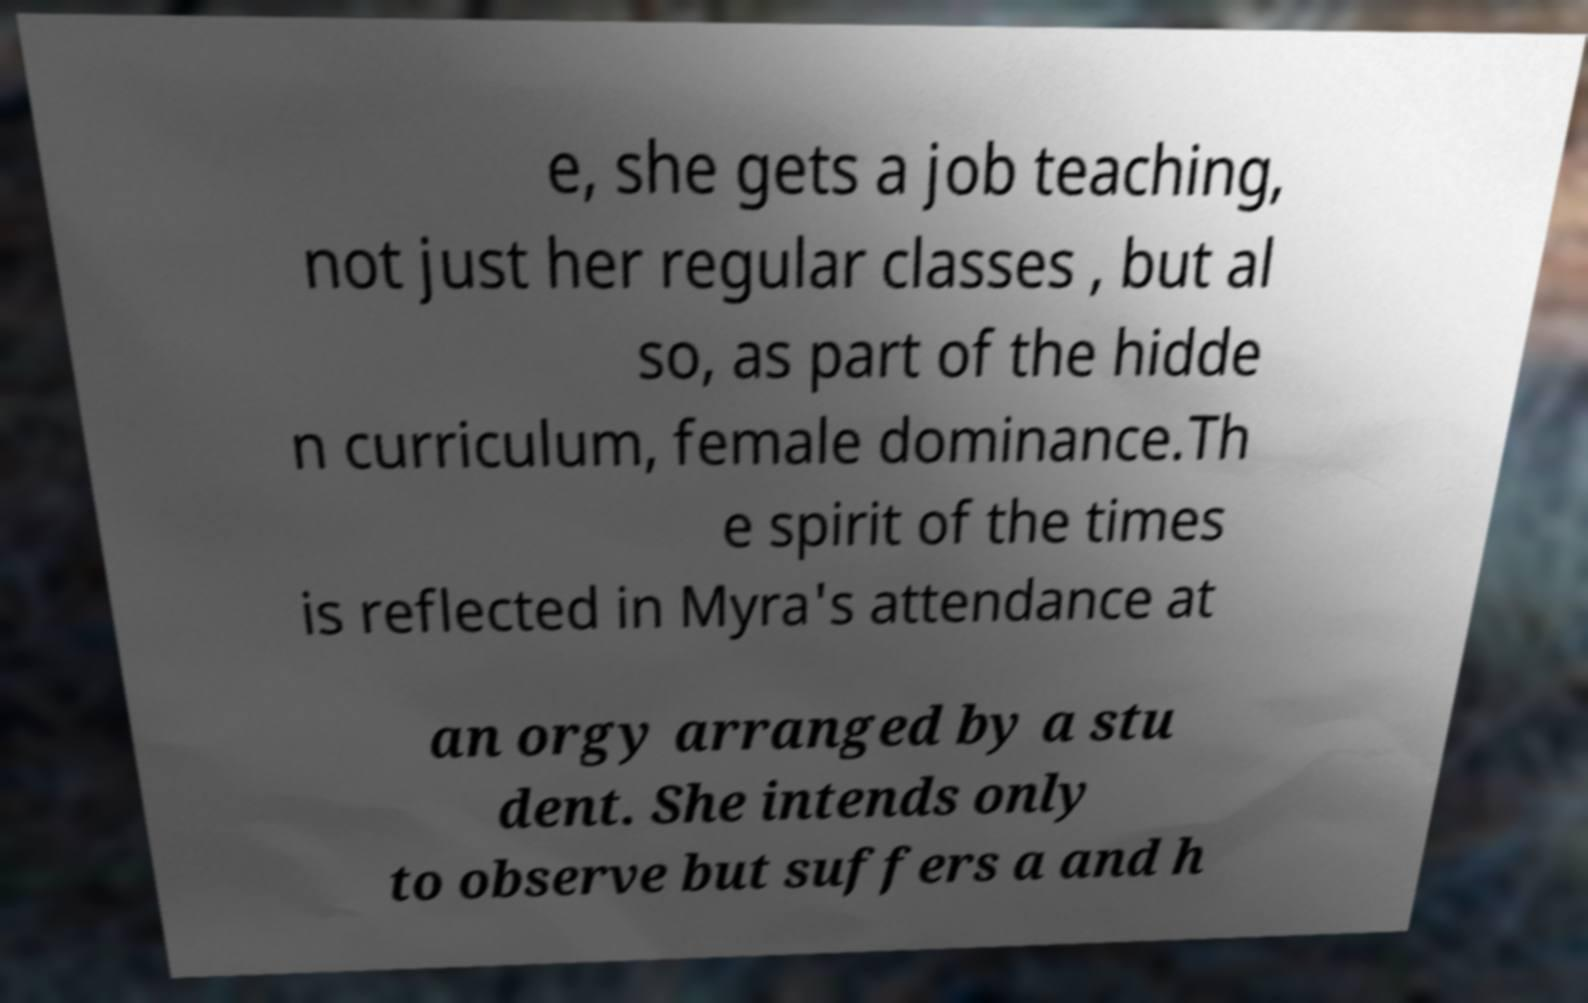Can you accurately transcribe the text from the provided image for me? e, she gets a job teaching, not just her regular classes , but al so, as part of the hidde n curriculum, female dominance.Th e spirit of the times is reflected in Myra's attendance at an orgy arranged by a stu dent. She intends only to observe but suffers a and h 